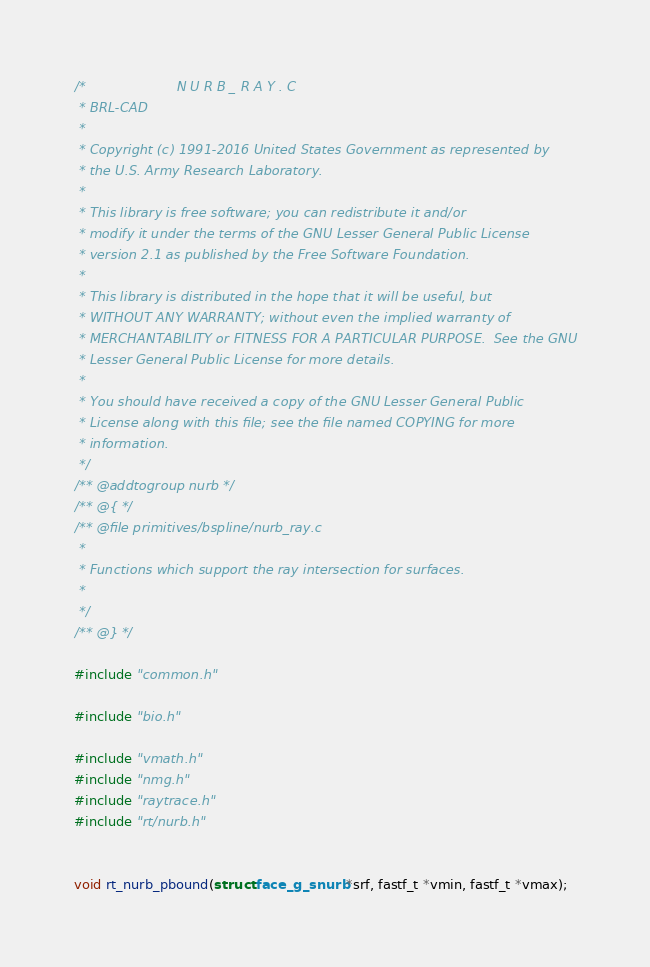<code> <loc_0><loc_0><loc_500><loc_500><_C_>/*                      N U R B _ R A Y . C
 * BRL-CAD
 *
 * Copyright (c) 1991-2016 United States Government as represented by
 * the U.S. Army Research Laboratory.
 *
 * This library is free software; you can redistribute it and/or
 * modify it under the terms of the GNU Lesser General Public License
 * version 2.1 as published by the Free Software Foundation.
 *
 * This library is distributed in the hope that it will be useful, but
 * WITHOUT ANY WARRANTY; without even the implied warranty of
 * MERCHANTABILITY or FITNESS FOR A PARTICULAR PURPOSE.  See the GNU
 * Lesser General Public License for more details.
 *
 * You should have received a copy of the GNU Lesser General Public
 * License along with this file; see the file named COPYING for more
 * information.
 */
/** @addtogroup nurb */
/** @{ */
/** @file primitives/bspline/nurb_ray.c
 *
 * Functions which support the ray intersection for surfaces.
 *
 */
/** @} */

#include "common.h"

#include "bio.h"

#include "vmath.h"
#include "nmg.h"
#include "raytrace.h"
#include "rt/nurb.h"


void rt_nurb_pbound(struct face_g_snurb *srf, fastf_t *vmin, fastf_t *vmax);
</code> 